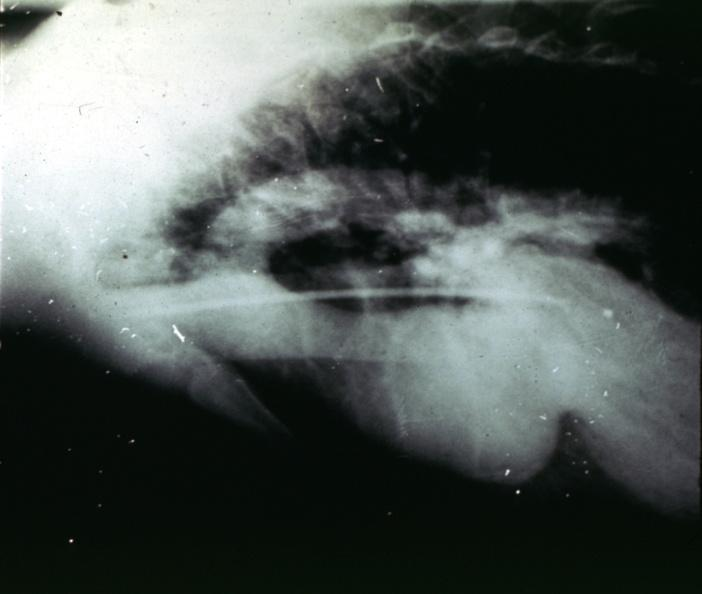does this image show marfans syndrome?
Answer the question using a single word or phrase. Yes 